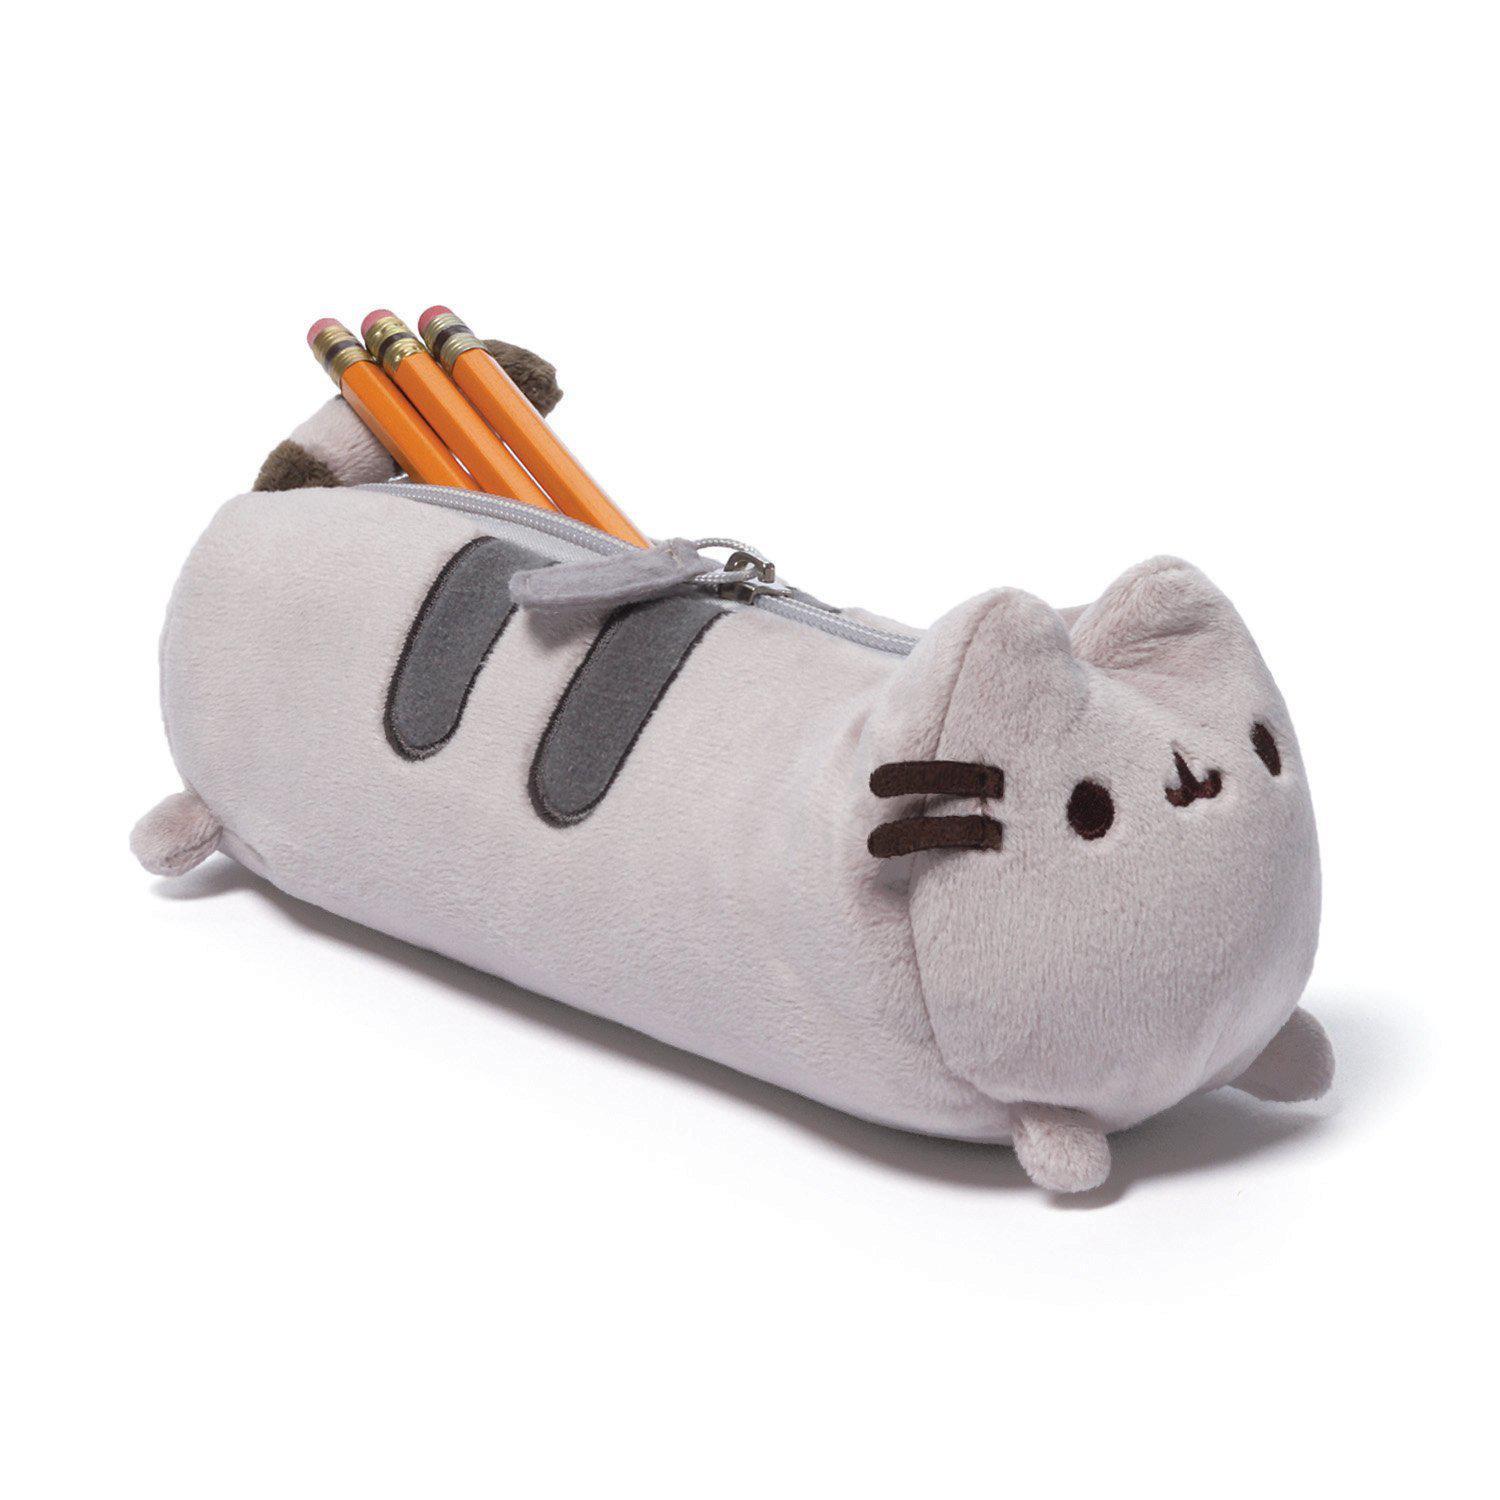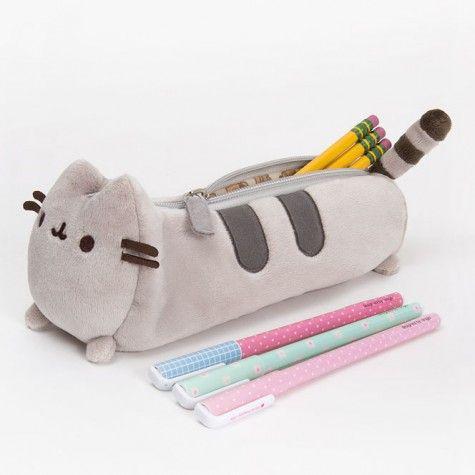The first image is the image on the left, the second image is the image on the right. Evaluate the accuracy of this statement regarding the images: "All the pencil cases feature animal-inspired shapes.". Is it true? Answer yes or no. Yes. 